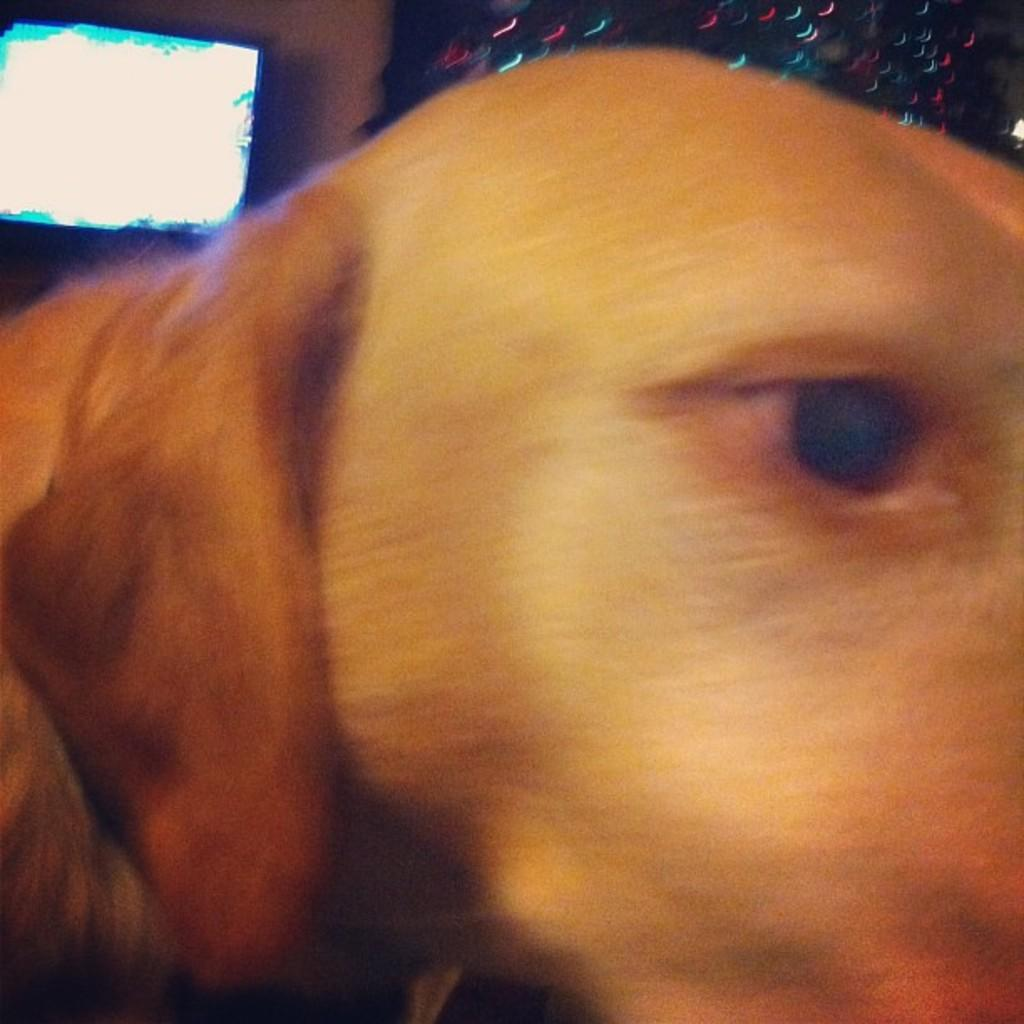What is the main subject of the image? The main subject of the image is a dog's face. What can be seen in the background of the image? There is a television in the background of the image. How is the television positioned in the image? The television is attached to the wall. What type of statement can be seen on the dog's face in the image? There are no statements visible on the dog's face in the image. What color is the yarn used to create the dog's face in the image? The image does not depict the dog's face being created with yarn, so we cannot determine the color of any yarn used. 